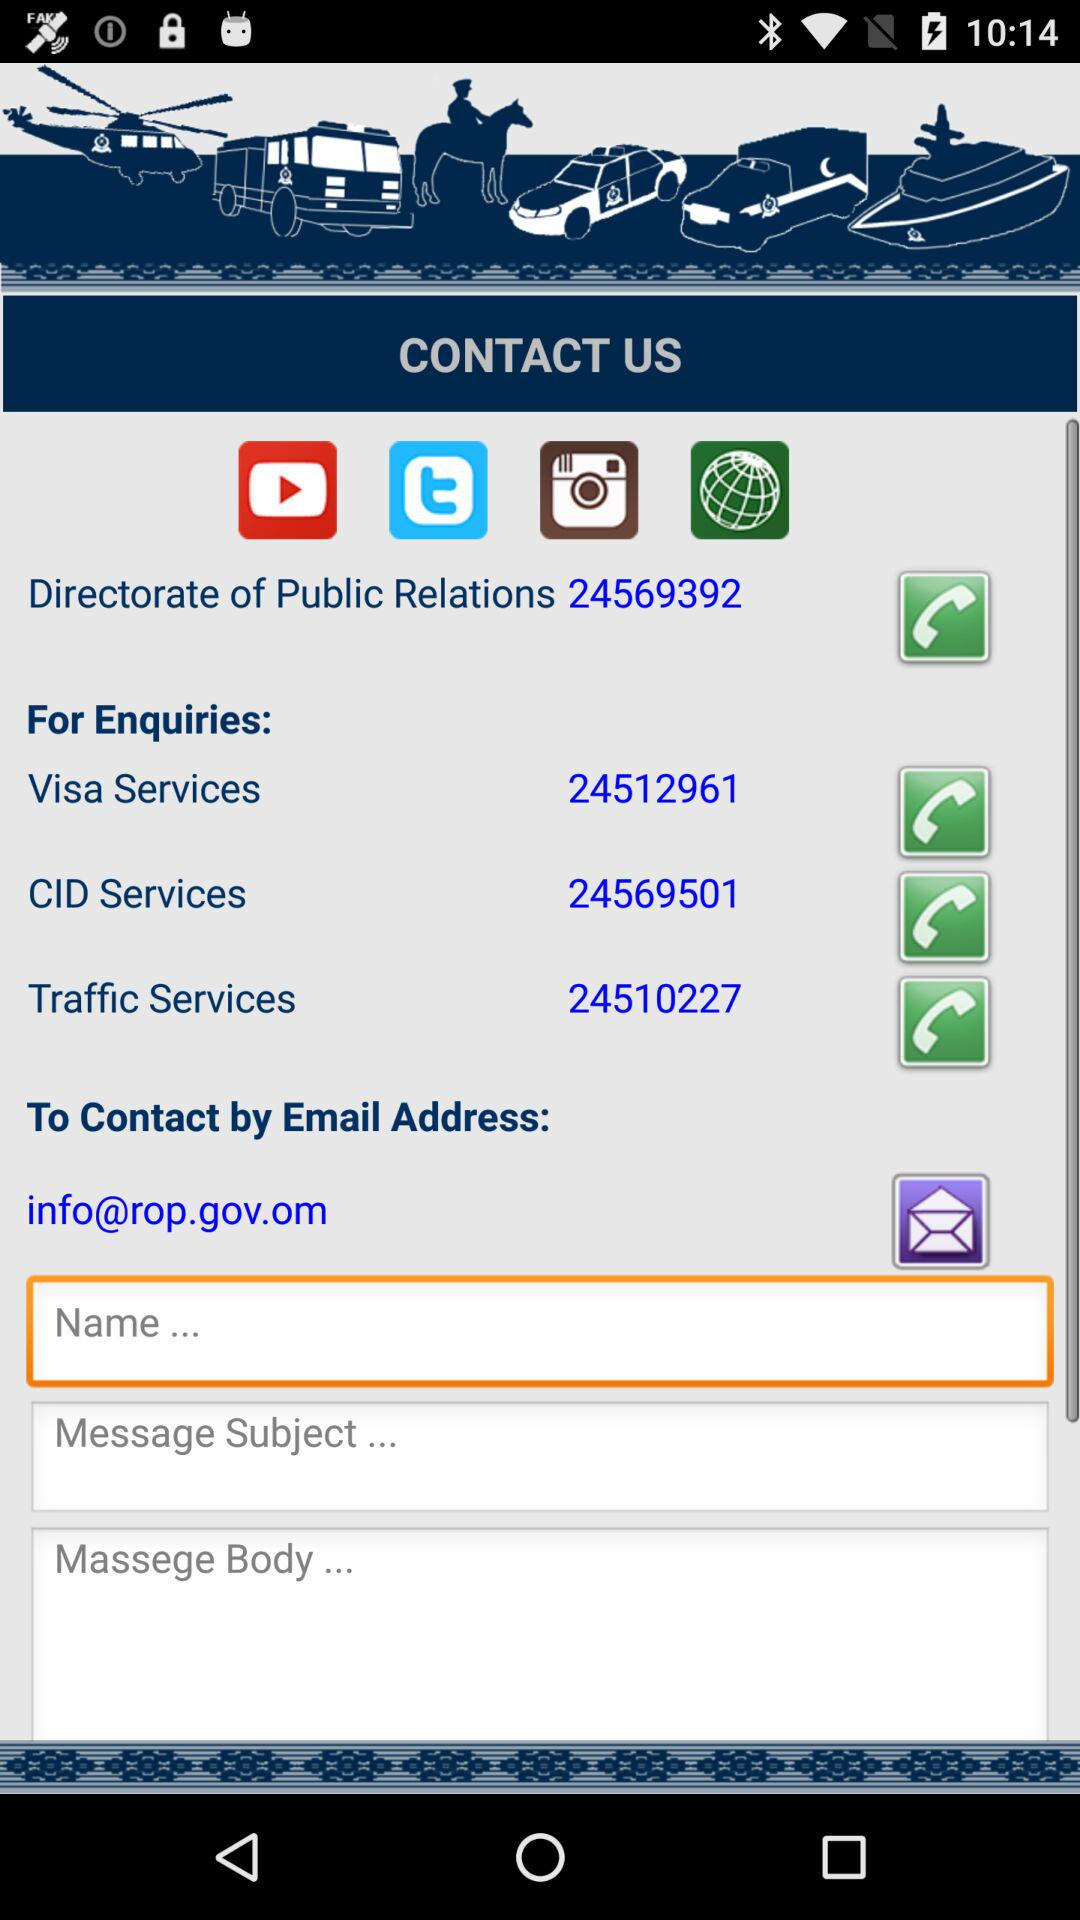What is the CID Services enquiry number? The enquiry number is 24569501. 